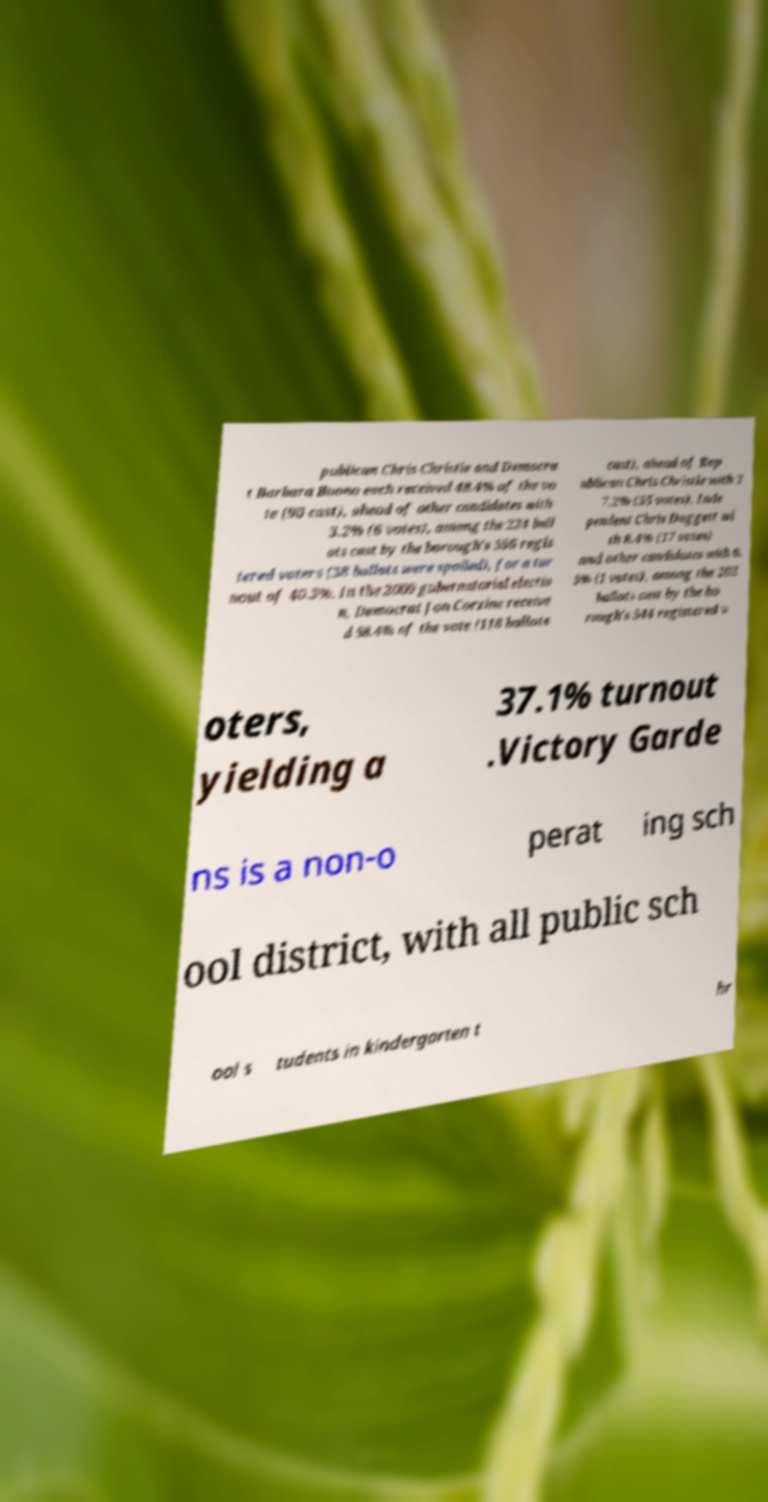I need the written content from this picture converted into text. Can you do that? publican Chris Christie and Democra t Barbara Buono each received 48.4% of the vo te (90 cast), ahead of other candidates with 3.2% (6 votes), among the 224 ball ots cast by the borough's 556 regis tered voters (38 ballots were spoiled), for a tur nout of 40.3%. In the 2009 gubernatorial electio n, Democrat Jon Corzine receive d 58.4% of the vote (118 ballots cast), ahead of Rep ublican Chris Christie with 2 7.2% (55 votes), Inde pendent Chris Daggett wi th 8.4% (17 votes) and other candidates with 0. 5% (1 votes), among the 202 ballots cast by the bo rough's 544 registered v oters, yielding a 37.1% turnout .Victory Garde ns is a non-o perat ing sch ool district, with all public sch ool s tudents in kindergarten t hr 